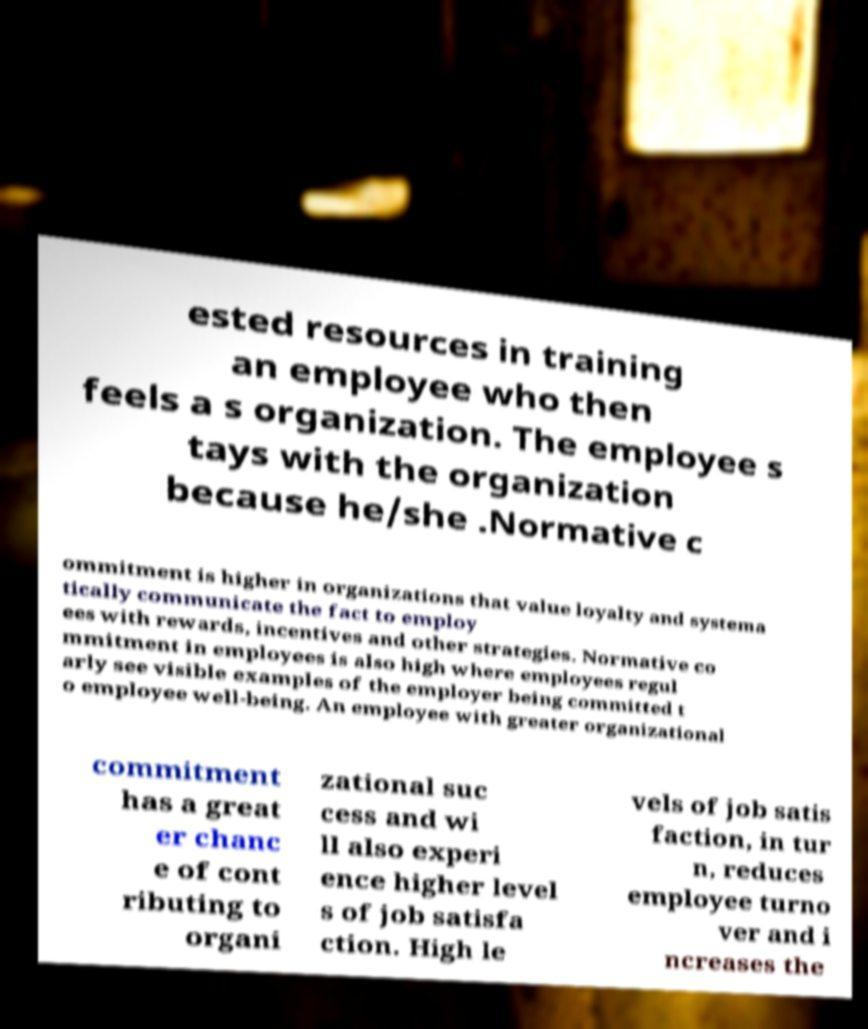Can you accurately transcribe the text from the provided image for me? ested resources in training an employee who then feels a s organization. The employee s tays with the organization because he/she .Normative c ommitment is higher in organizations that value loyalty and systema tically communicate the fact to employ ees with rewards, incentives and other strategies. Normative co mmitment in employees is also high where employees regul arly see visible examples of the employer being committed t o employee well-being. An employee with greater organizational commitment has a great er chanc e of cont ributing to organi zational suc cess and wi ll also experi ence higher level s of job satisfa ction. High le vels of job satis faction, in tur n, reduces employee turno ver and i ncreases the 